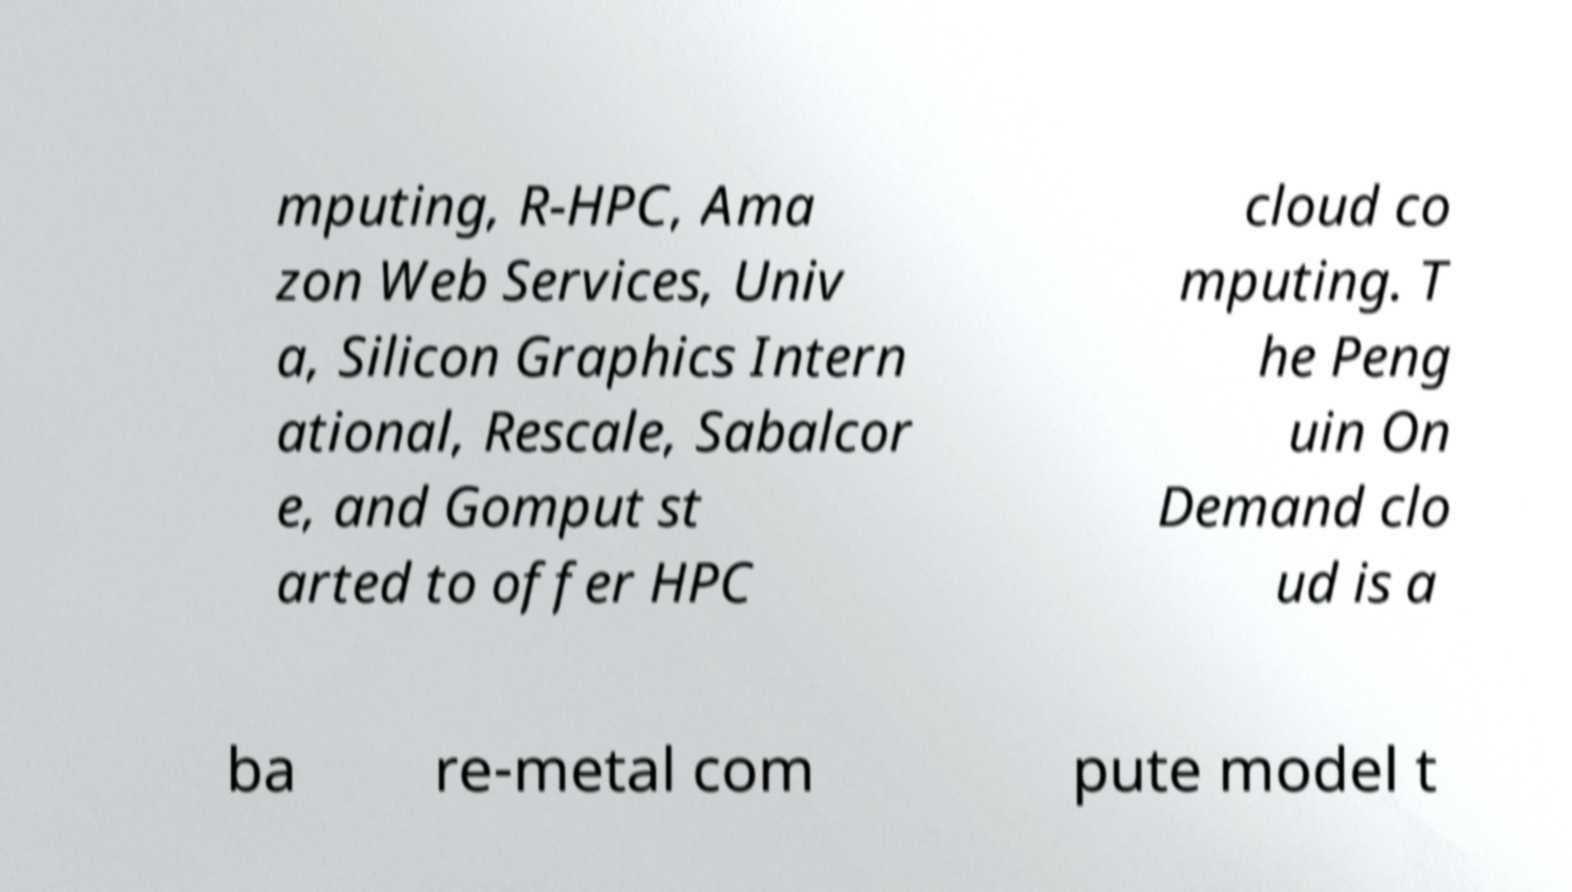Can you read and provide the text displayed in the image?This photo seems to have some interesting text. Can you extract and type it out for me? mputing, R-HPC, Ama zon Web Services, Univ a, Silicon Graphics Intern ational, Rescale, Sabalcor e, and Gomput st arted to offer HPC cloud co mputing. T he Peng uin On Demand clo ud is a ba re-metal com pute model t 